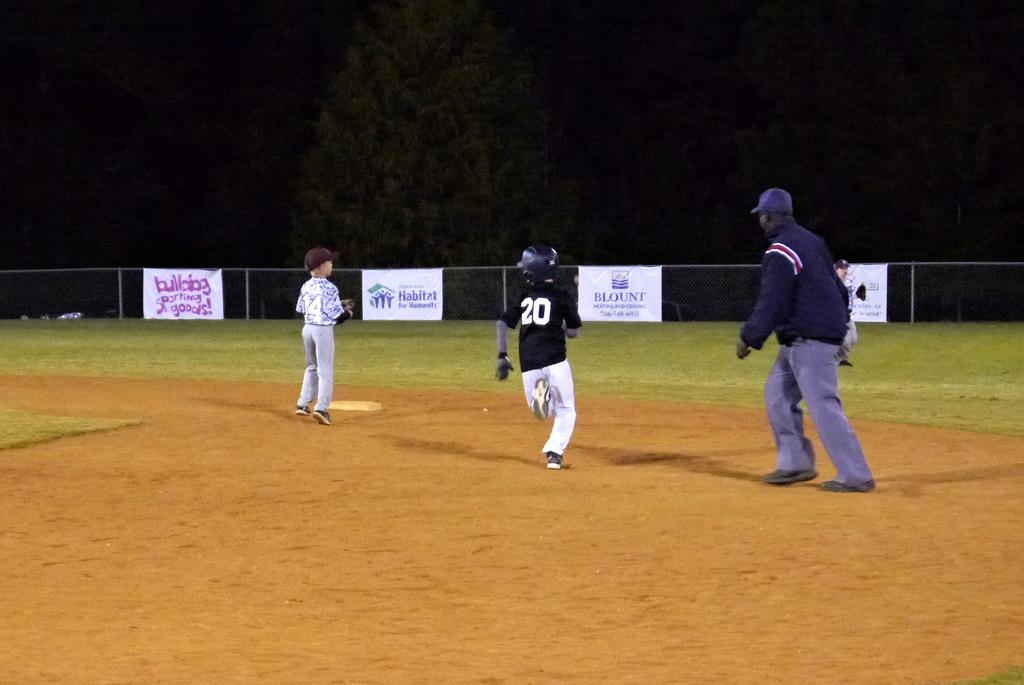Provide a one-sentence caption for the provided image. a player with the number 20 running around bases. 